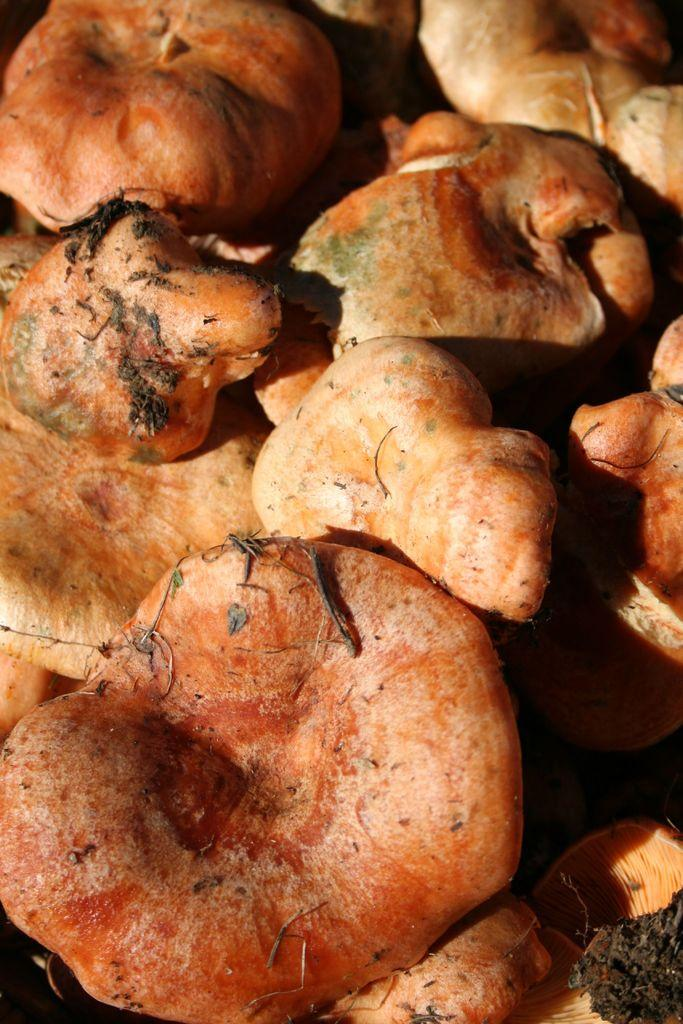What colors are present in the objects visible in the image? The objects in the image are orange and yellow in color. Is there a sweater in the image that is being used as a payment for a lawyer's services? There is no sweater or lawyer present in the image, and therefore no such transaction can be observed. 